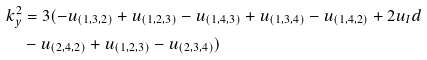<formula> <loc_0><loc_0><loc_500><loc_500>k _ { y } ^ { 2 } & = 3 ( - u _ { ( 1 , 3 , 2 ) } + u _ { ( 1 , 2 , 3 ) } - u _ { ( 1 , 4 , 3 ) } + u _ { ( 1 , 3 , 4 ) } - u _ { ( 1 , 4 , 2 ) } + 2 u _ { I } d \\ & - u _ { ( 2 , 4 , 2 ) } + u _ { ( 1 , 2 , 3 ) } - u _ { ( 2 , 3 , 4 ) } )</formula> 